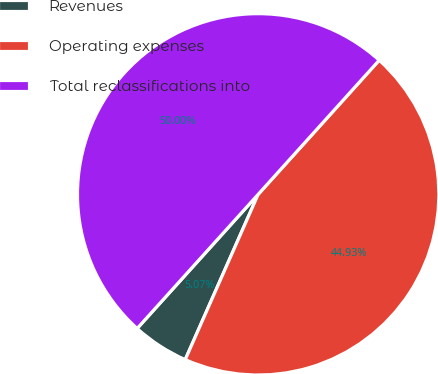Convert chart to OTSL. <chart><loc_0><loc_0><loc_500><loc_500><pie_chart><fcel>Revenues<fcel>Operating expenses<fcel>Total reclassifications into<nl><fcel>5.07%<fcel>44.93%<fcel>50.0%<nl></chart> 